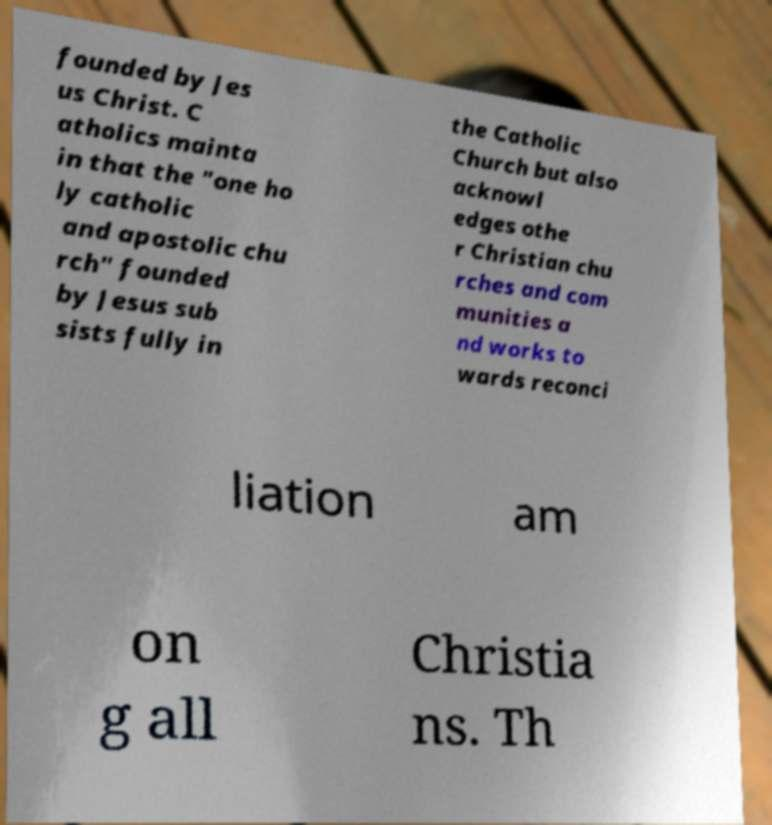For documentation purposes, I need the text within this image transcribed. Could you provide that? founded by Jes us Christ. C atholics mainta in that the "one ho ly catholic and apostolic chu rch" founded by Jesus sub sists fully in the Catholic Church but also acknowl edges othe r Christian chu rches and com munities a nd works to wards reconci liation am on g all Christia ns. Th 